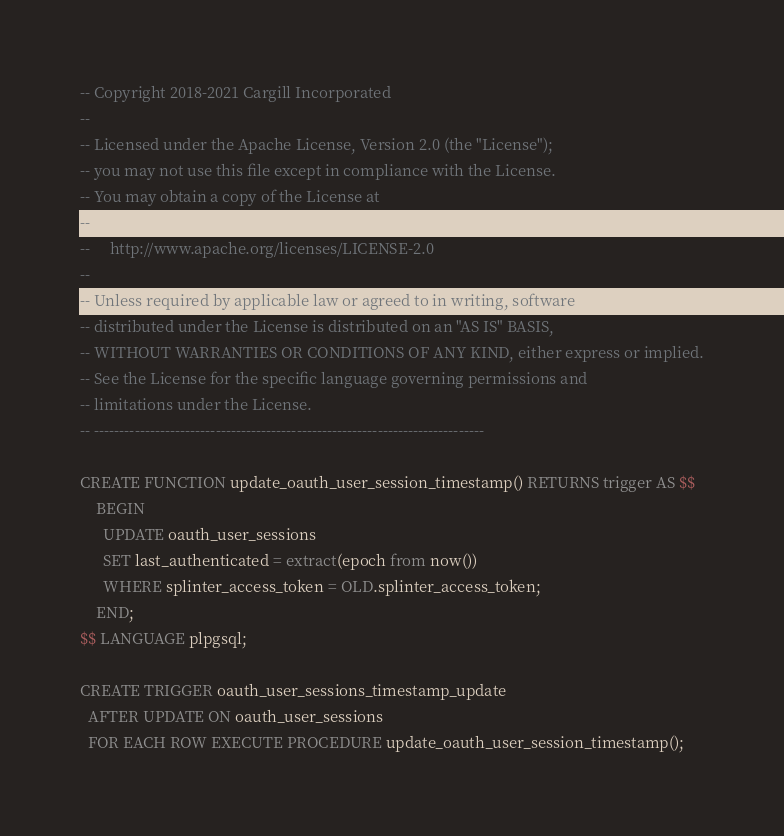Convert code to text. <code><loc_0><loc_0><loc_500><loc_500><_SQL_>-- Copyright 2018-2021 Cargill Incorporated
--
-- Licensed under the Apache License, Version 2.0 (the "License");
-- you may not use this file except in compliance with the License.
-- You may obtain a copy of the License at
--
--     http://www.apache.org/licenses/LICENSE-2.0
--
-- Unless required by applicable law or agreed to in writing, software
-- distributed under the License is distributed on an "AS IS" BASIS,
-- WITHOUT WARRANTIES OR CONDITIONS OF ANY KIND, either express or implied.
-- See the License for the specific language governing permissions and
-- limitations under the License.
-- -----------------------------------------------------------------------------

CREATE FUNCTION update_oauth_user_session_timestamp() RETURNS trigger AS $$
    BEGIN
      UPDATE oauth_user_sessions
      SET last_authenticated = extract(epoch from now())
      WHERE splinter_access_token = OLD.splinter_access_token;
    END;
$$ LANGUAGE plpgsql;

CREATE TRIGGER oauth_user_sessions_timestamp_update
  AFTER UPDATE ON oauth_user_sessions
  FOR EACH ROW EXECUTE PROCEDURE update_oauth_user_session_timestamp();
</code> 